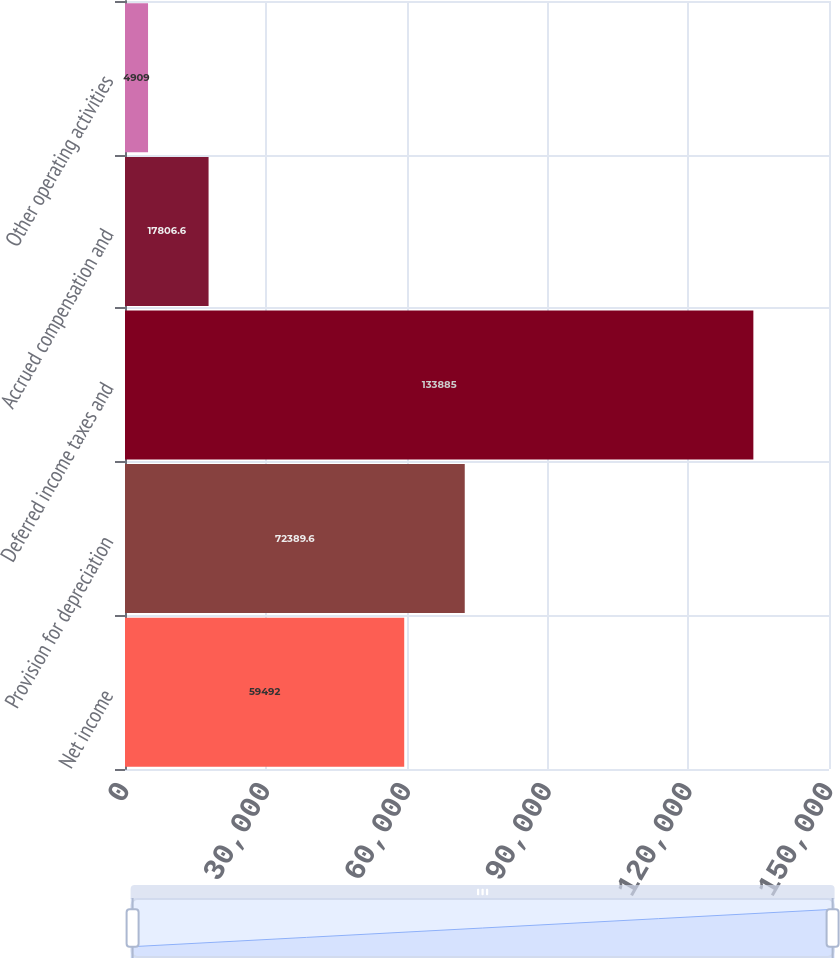<chart> <loc_0><loc_0><loc_500><loc_500><bar_chart><fcel>Net income<fcel>Provision for depreciation<fcel>Deferred income taxes and<fcel>Accrued compensation and<fcel>Other operating activities<nl><fcel>59492<fcel>72389.6<fcel>133885<fcel>17806.6<fcel>4909<nl></chart> 